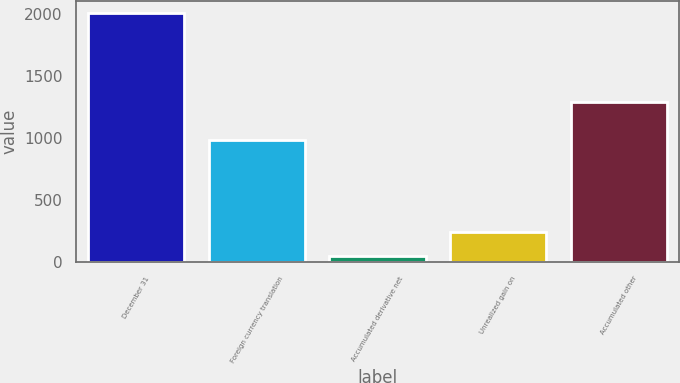<chart> <loc_0><loc_0><loc_500><loc_500><bar_chart><fcel>December 31<fcel>Foreign currency translation<fcel>Accumulated derivative net<fcel>Unrealized gain on<fcel>Accumulated other<nl><fcel>2006<fcel>984<fcel>49<fcel>244.7<fcel>1291<nl></chart> 